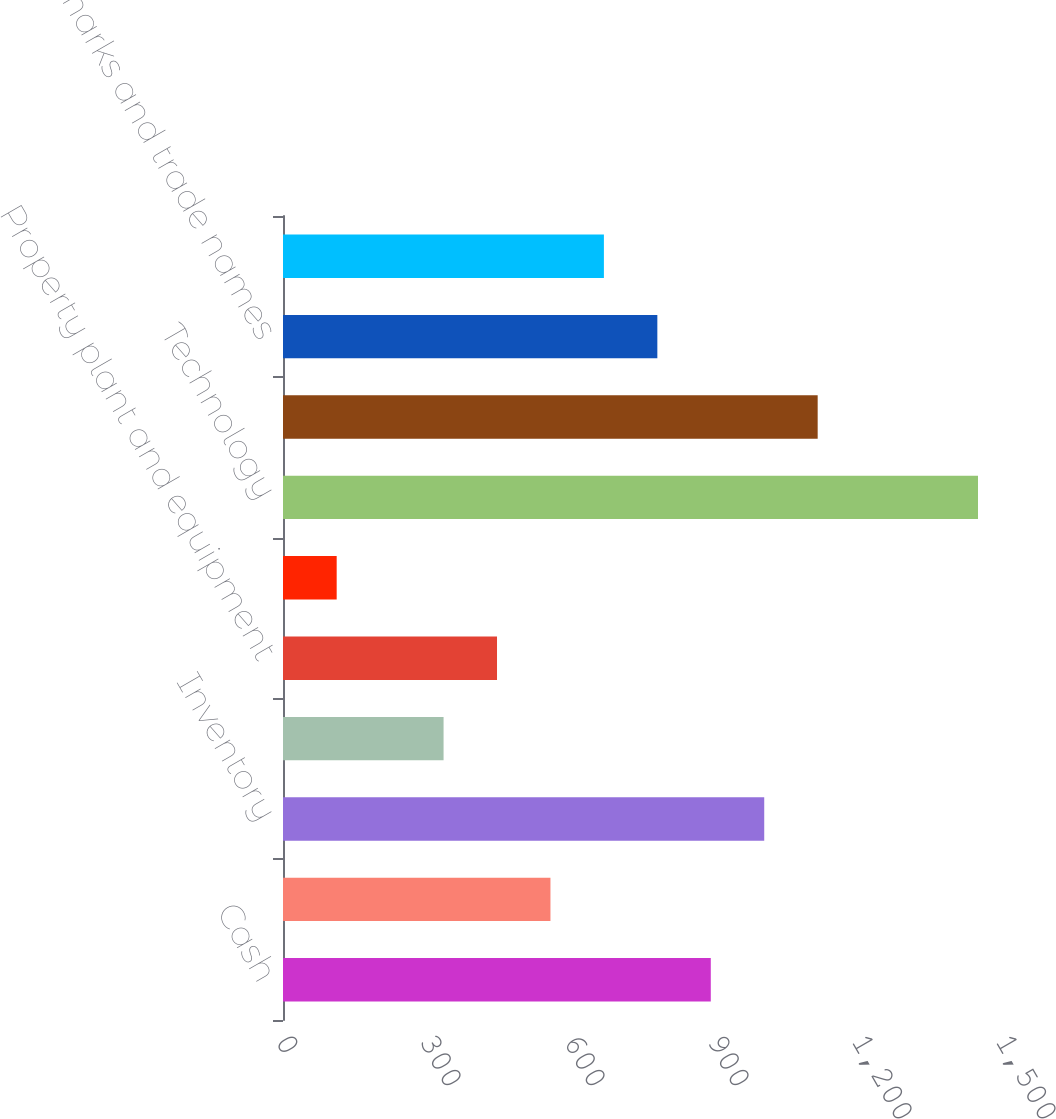<chart> <loc_0><loc_0><loc_500><loc_500><bar_chart><fcel>Cash<fcel>Accounts receivable net<fcel>Inventory<fcel>Other current assets<fcel>Property plant and equipment<fcel>Intangible assets not subject<fcel>Technology<fcel>Customer relationships<fcel>Trademarks and trade names<fcel>Other assets<nl><fcel>891.22<fcel>557.2<fcel>1002.56<fcel>334.52<fcel>445.86<fcel>111.84<fcel>1447.92<fcel>1113.9<fcel>779.88<fcel>668.54<nl></chart> 